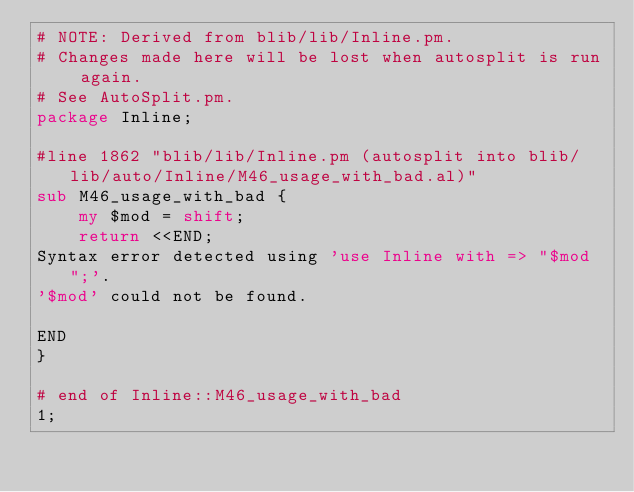<code> <loc_0><loc_0><loc_500><loc_500><_Perl_># NOTE: Derived from blib/lib/Inline.pm.
# Changes made here will be lost when autosplit is run again.
# See AutoSplit.pm.
package Inline;

#line 1862 "blib/lib/Inline.pm (autosplit into blib/lib/auto/Inline/M46_usage_with_bad.al)"
sub M46_usage_with_bad {
    my $mod = shift;
    return <<END;
Syntax error detected using 'use Inline with => "$mod";'.
'$mod' could not be found.

END
}

# end of Inline::M46_usage_with_bad
1;
</code> 